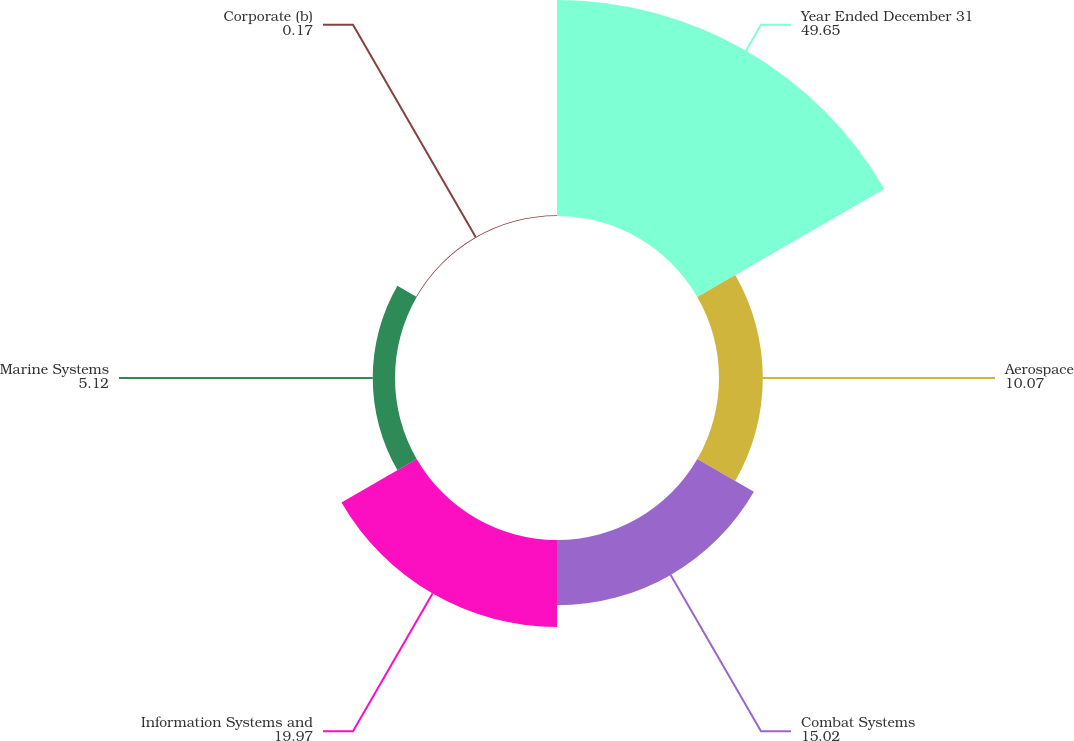Convert chart to OTSL. <chart><loc_0><loc_0><loc_500><loc_500><pie_chart><fcel>Year Ended December 31<fcel>Aerospace<fcel>Combat Systems<fcel>Information Systems and<fcel>Marine Systems<fcel>Corporate (b)<nl><fcel>49.65%<fcel>10.07%<fcel>15.02%<fcel>19.97%<fcel>5.12%<fcel>0.17%<nl></chart> 